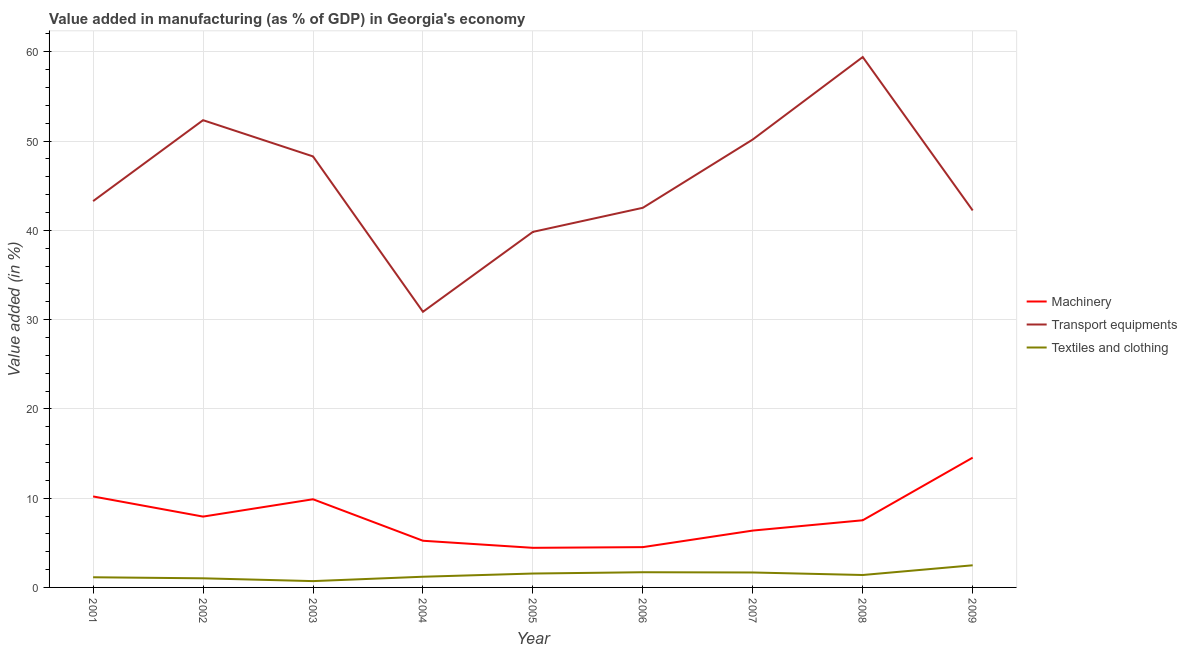Does the line corresponding to value added in manufacturing machinery intersect with the line corresponding to value added in manufacturing textile and clothing?
Keep it short and to the point. No. Is the number of lines equal to the number of legend labels?
Your answer should be very brief. Yes. What is the value added in manufacturing transport equipments in 2008?
Keep it short and to the point. 59.41. Across all years, what is the maximum value added in manufacturing machinery?
Provide a succinct answer. 14.54. Across all years, what is the minimum value added in manufacturing machinery?
Provide a short and direct response. 4.44. In which year was the value added in manufacturing transport equipments maximum?
Give a very brief answer. 2008. In which year was the value added in manufacturing transport equipments minimum?
Make the answer very short. 2004. What is the total value added in manufacturing transport equipments in the graph?
Offer a terse response. 408.9. What is the difference between the value added in manufacturing transport equipments in 2004 and that in 2009?
Your answer should be compact. -11.35. What is the difference between the value added in manufacturing machinery in 2008 and the value added in manufacturing transport equipments in 2005?
Your response must be concise. -32.3. What is the average value added in manufacturing textile and clothing per year?
Provide a short and direct response. 1.43. In the year 2005, what is the difference between the value added in manufacturing transport equipments and value added in manufacturing machinery?
Your response must be concise. 35.39. What is the ratio of the value added in manufacturing textile and clothing in 2004 to that in 2006?
Give a very brief answer. 0.7. Is the value added in manufacturing textile and clothing in 2003 less than that in 2004?
Your answer should be compact. Yes. Is the difference between the value added in manufacturing machinery in 2003 and 2007 greater than the difference between the value added in manufacturing transport equipments in 2003 and 2007?
Make the answer very short. Yes. What is the difference between the highest and the second highest value added in manufacturing machinery?
Your answer should be very brief. 4.35. What is the difference between the highest and the lowest value added in manufacturing machinery?
Ensure brevity in your answer.  10.1. In how many years, is the value added in manufacturing textile and clothing greater than the average value added in manufacturing textile and clothing taken over all years?
Make the answer very short. 4. Is the value added in manufacturing machinery strictly greater than the value added in manufacturing textile and clothing over the years?
Make the answer very short. Yes. How many lines are there?
Provide a short and direct response. 3. How many years are there in the graph?
Make the answer very short. 9. Are the values on the major ticks of Y-axis written in scientific E-notation?
Your answer should be very brief. No. Does the graph contain any zero values?
Provide a short and direct response. No. How many legend labels are there?
Keep it short and to the point. 3. What is the title of the graph?
Your answer should be compact. Value added in manufacturing (as % of GDP) in Georgia's economy. What is the label or title of the Y-axis?
Offer a very short reply. Value added (in %). What is the Value added (in %) in Machinery in 2001?
Offer a terse response. 10.19. What is the Value added (in %) of Transport equipments in 2001?
Keep it short and to the point. 43.27. What is the Value added (in %) of Textiles and clothing in 2001?
Your answer should be compact. 1.14. What is the Value added (in %) of Machinery in 2002?
Offer a very short reply. 7.93. What is the Value added (in %) in Transport equipments in 2002?
Provide a short and direct response. 52.33. What is the Value added (in %) in Textiles and clothing in 2002?
Your response must be concise. 1.02. What is the Value added (in %) of Machinery in 2003?
Make the answer very short. 9.88. What is the Value added (in %) of Transport equipments in 2003?
Ensure brevity in your answer.  48.28. What is the Value added (in %) of Textiles and clothing in 2003?
Your answer should be compact. 0.71. What is the Value added (in %) of Machinery in 2004?
Make the answer very short. 5.23. What is the Value added (in %) of Transport equipments in 2004?
Provide a short and direct response. 30.87. What is the Value added (in %) in Textiles and clothing in 2004?
Ensure brevity in your answer.  1.2. What is the Value added (in %) of Machinery in 2005?
Your answer should be very brief. 4.44. What is the Value added (in %) of Transport equipments in 2005?
Keep it short and to the point. 39.82. What is the Value added (in %) in Textiles and clothing in 2005?
Provide a short and direct response. 1.56. What is the Value added (in %) in Machinery in 2006?
Your answer should be very brief. 4.51. What is the Value added (in %) in Transport equipments in 2006?
Offer a terse response. 42.52. What is the Value added (in %) in Textiles and clothing in 2006?
Ensure brevity in your answer.  1.7. What is the Value added (in %) in Machinery in 2007?
Offer a terse response. 6.37. What is the Value added (in %) of Transport equipments in 2007?
Give a very brief answer. 50.17. What is the Value added (in %) in Textiles and clothing in 2007?
Make the answer very short. 1.67. What is the Value added (in %) of Machinery in 2008?
Offer a terse response. 7.52. What is the Value added (in %) of Transport equipments in 2008?
Provide a short and direct response. 59.41. What is the Value added (in %) in Textiles and clothing in 2008?
Your answer should be compact. 1.39. What is the Value added (in %) of Machinery in 2009?
Make the answer very short. 14.54. What is the Value added (in %) of Transport equipments in 2009?
Your answer should be very brief. 42.22. What is the Value added (in %) in Textiles and clothing in 2009?
Your answer should be compact. 2.48. Across all years, what is the maximum Value added (in %) in Machinery?
Keep it short and to the point. 14.54. Across all years, what is the maximum Value added (in %) in Transport equipments?
Provide a succinct answer. 59.41. Across all years, what is the maximum Value added (in %) in Textiles and clothing?
Give a very brief answer. 2.48. Across all years, what is the minimum Value added (in %) of Machinery?
Your response must be concise. 4.44. Across all years, what is the minimum Value added (in %) in Transport equipments?
Your answer should be very brief. 30.87. Across all years, what is the minimum Value added (in %) in Textiles and clothing?
Your answer should be very brief. 0.71. What is the total Value added (in %) of Machinery in the graph?
Your answer should be very brief. 70.61. What is the total Value added (in %) in Transport equipments in the graph?
Provide a short and direct response. 408.9. What is the total Value added (in %) in Textiles and clothing in the graph?
Your answer should be very brief. 12.87. What is the difference between the Value added (in %) of Machinery in 2001 and that in 2002?
Provide a short and direct response. 2.26. What is the difference between the Value added (in %) of Transport equipments in 2001 and that in 2002?
Your answer should be compact. -9.07. What is the difference between the Value added (in %) in Textiles and clothing in 2001 and that in 2002?
Offer a terse response. 0.12. What is the difference between the Value added (in %) of Machinery in 2001 and that in 2003?
Offer a very short reply. 0.31. What is the difference between the Value added (in %) in Transport equipments in 2001 and that in 2003?
Your answer should be very brief. -5.01. What is the difference between the Value added (in %) of Textiles and clothing in 2001 and that in 2003?
Give a very brief answer. 0.43. What is the difference between the Value added (in %) of Machinery in 2001 and that in 2004?
Offer a very short reply. 4.96. What is the difference between the Value added (in %) in Transport equipments in 2001 and that in 2004?
Keep it short and to the point. 12.4. What is the difference between the Value added (in %) in Textiles and clothing in 2001 and that in 2004?
Your answer should be compact. -0.06. What is the difference between the Value added (in %) in Machinery in 2001 and that in 2005?
Your response must be concise. 5.75. What is the difference between the Value added (in %) of Transport equipments in 2001 and that in 2005?
Offer a terse response. 3.44. What is the difference between the Value added (in %) of Textiles and clothing in 2001 and that in 2005?
Make the answer very short. -0.42. What is the difference between the Value added (in %) of Machinery in 2001 and that in 2006?
Make the answer very short. 5.68. What is the difference between the Value added (in %) of Transport equipments in 2001 and that in 2006?
Ensure brevity in your answer.  0.75. What is the difference between the Value added (in %) in Textiles and clothing in 2001 and that in 2006?
Make the answer very short. -0.56. What is the difference between the Value added (in %) of Machinery in 2001 and that in 2007?
Provide a succinct answer. 3.82. What is the difference between the Value added (in %) of Transport equipments in 2001 and that in 2007?
Provide a short and direct response. -6.9. What is the difference between the Value added (in %) in Textiles and clothing in 2001 and that in 2007?
Your answer should be compact. -0.54. What is the difference between the Value added (in %) of Machinery in 2001 and that in 2008?
Provide a succinct answer. 2.67. What is the difference between the Value added (in %) in Transport equipments in 2001 and that in 2008?
Offer a very short reply. -16.14. What is the difference between the Value added (in %) in Textiles and clothing in 2001 and that in 2008?
Keep it short and to the point. -0.25. What is the difference between the Value added (in %) of Machinery in 2001 and that in 2009?
Provide a short and direct response. -4.35. What is the difference between the Value added (in %) of Transport equipments in 2001 and that in 2009?
Provide a succinct answer. 1.04. What is the difference between the Value added (in %) of Textiles and clothing in 2001 and that in 2009?
Provide a short and direct response. -1.34. What is the difference between the Value added (in %) of Machinery in 2002 and that in 2003?
Ensure brevity in your answer.  -1.94. What is the difference between the Value added (in %) in Transport equipments in 2002 and that in 2003?
Your answer should be very brief. 4.06. What is the difference between the Value added (in %) in Textiles and clothing in 2002 and that in 2003?
Give a very brief answer. 0.31. What is the difference between the Value added (in %) in Machinery in 2002 and that in 2004?
Your response must be concise. 2.71. What is the difference between the Value added (in %) in Transport equipments in 2002 and that in 2004?
Your answer should be very brief. 21.46. What is the difference between the Value added (in %) of Textiles and clothing in 2002 and that in 2004?
Your answer should be compact. -0.18. What is the difference between the Value added (in %) in Machinery in 2002 and that in 2005?
Ensure brevity in your answer.  3.5. What is the difference between the Value added (in %) in Transport equipments in 2002 and that in 2005?
Your answer should be compact. 12.51. What is the difference between the Value added (in %) of Textiles and clothing in 2002 and that in 2005?
Give a very brief answer. -0.54. What is the difference between the Value added (in %) of Machinery in 2002 and that in 2006?
Offer a terse response. 3.42. What is the difference between the Value added (in %) of Transport equipments in 2002 and that in 2006?
Your response must be concise. 9.81. What is the difference between the Value added (in %) of Textiles and clothing in 2002 and that in 2006?
Your response must be concise. -0.68. What is the difference between the Value added (in %) of Machinery in 2002 and that in 2007?
Offer a very short reply. 1.57. What is the difference between the Value added (in %) in Transport equipments in 2002 and that in 2007?
Your answer should be compact. 2.16. What is the difference between the Value added (in %) in Textiles and clothing in 2002 and that in 2007?
Give a very brief answer. -0.65. What is the difference between the Value added (in %) of Machinery in 2002 and that in 2008?
Provide a succinct answer. 0.41. What is the difference between the Value added (in %) in Transport equipments in 2002 and that in 2008?
Give a very brief answer. -7.07. What is the difference between the Value added (in %) of Textiles and clothing in 2002 and that in 2008?
Your answer should be compact. -0.37. What is the difference between the Value added (in %) of Machinery in 2002 and that in 2009?
Your answer should be very brief. -6.6. What is the difference between the Value added (in %) in Transport equipments in 2002 and that in 2009?
Your response must be concise. 10.11. What is the difference between the Value added (in %) in Textiles and clothing in 2002 and that in 2009?
Your response must be concise. -1.46. What is the difference between the Value added (in %) in Machinery in 2003 and that in 2004?
Offer a terse response. 4.65. What is the difference between the Value added (in %) in Transport equipments in 2003 and that in 2004?
Make the answer very short. 17.4. What is the difference between the Value added (in %) in Textiles and clothing in 2003 and that in 2004?
Your answer should be very brief. -0.49. What is the difference between the Value added (in %) in Machinery in 2003 and that in 2005?
Ensure brevity in your answer.  5.44. What is the difference between the Value added (in %) of Transport equipments in 2003 and that in 2005?
Make the answer very short. 8.45. What is the difference between the Value added (in %) of Textiles and clothing in 2003 and that in 2005?
Make the answer very short. -0.85. What is the difference between the Value added (in %) in Machinery in 2003 and that in 2006?
Your response must be concise. 5.36. What is the difference between the Value added (in %) of Transport equipments in 2003 and that in 2006?
Your answer should be compact. 5.75. What is the difference between the Value added (in %) of Textiles and clothing in 2003 and that in 2006?
Keep it short and to the point. -0.99. What is the difference between the Value added (in %) of Machinery in 2003 and that in 2007?
Your answer should be compact. 3.51. What is the difference between the Value added (in %) of Transport equipments in 2003 and that in 2007?
Offer a very short reply. -1.9. What is the difference between the Value added (in %) of Textiles and clothing in 2003 and that in 2007?
Offer a very short reply. -0.96. What is the difference between the Value added (in %) in Machinery in 2003 and that in 2008?
Provide a short and direct response. 2.35. What is the difference between the Value added (in %) of Transport equipments in 2003 and that in 2008?
Your answer should be very brief. -11.13. What is the difference between the Value added (in %) in Textiles and clothing in 2003 and that in 2008?
Your answer should be compact. -0.68. What is the difference between the Value added (in %) of Machinery in 2003 and that in 2009?
Make the answer very short. -4.66. What is the difference between the Value added (in %) of Transport equipments in 2003 and that in 2009?
Your answer should be compact. 6.05. What is the difference between the Value added (in %) in Textiles and clothing in 2003 and that in 2009?
Your response must be concise. -1.77. What is the difference between the Value added (in %) of Machinery in 2004 and that in 2005?
Provide a succinct answer. 0.79. What is the difference between the Value added (in %) in Transport equipments in 2004 and that in 2005?
Offer a terse response. -8.95. What is the difference between the Value added (in %) in Textiles and clothing in 2004 and that in 2005?
Your answer should be very brief. -0.36. What is the difference between the Value added (in %) of Machinery in 2004 and that in 2006?
Your response must be concise. 0.71. What is the difference between the Value added (in %) in Transport equipments in 2004 and that in 2006?
Give a very brief answer. -11.65. What is the difference between the Value added (in %) in Textiles and clothing in 2004 and that in 2006?
Your answer should be very brief. -0.51. What is the difference between the Value added (in %) of Machinery in 2004 and that in 2007?
Give a very brief answer. -1.14. What is the difference between the Value added (in %) in Transport equipments in 2004 and that in 2007?
Your response must be concise. -19.3. What is the difference between the Value added (in %) in Textiles and clothing in 2004 and that in 2007?
Provide a short and direct response. -0.48. What is the difference between the Value added (in %) of Machinery in 2004 and that in 2008?
Provide a short and direct response. -2.29. What is the difference between the Value added (in %) in Transport equipments in 2004 and that in 2008?
Your response must be concise. -28.53. What is the difference between the Value added (in %) of Textiles and clothing in 2004 and that in 2008?
Give a very brief answer. -0.2. What is the difference between the Value added (in %) in Machinery in 2004 and that in 2009?
Keep it short and to the point. -9.31. What is the difference between the Value added (in %) in Transport equipments in 2004 and that in 2009?
Give a very brief answer. -11.35. What is the difference between the Value added (in %) of Textiles and clothing in 2004 and that in 2009?
Ensure brevity in your answer.  -1.28. What is the difference between the Value added (in %) in Machinery in 2005 and that in 2006?
Provide a short and direct response. -0.08. What is the difference between the Value added (in %) in Transport equipments in 2005 and that in 2006?
Your answer should be compact. -2.7. What is the difference between the Value added (in %) in Textiles and clothing in 2005 and that in 2006?
Make the answer very short. -0.15. What is the difference between the Value added (in %) in Machinery in 2005 and that in 2007?
Make the answer very short. -1.93. What is the difference between the Value added (in %) of Transport equipments in 2005 and that in 2007?
Your response must be concise. -10.35. What is the difference between the Value added (in %) in Textiles and clothing in 2005 and that in 2007?
Your response must be concise. -0.12. What is the difference between the Value added (in %) of Machinery in 2005 and that in 2008?
Ensure brevity in your answer.  -3.09. What is the difference between the Value added (in %) of Transport equipments in 2005 and that in 2008?
Offer a terse response. -19.58. What is the difference between the Value added (in %) of Textiles and clothing in 2005 and that in 2008?
Give a very brief answer. 0.16. What is the difference between the Value added (in %) in Machinery in 2005 and that in 2009?
Offer a very short reply. -10.1. What is the difference between the Value added (in %) of Textiles and clothing in 2005 and that in 2009?
Provide a succinct answer. -0.92. What is the difference between the Value added (in %) of Machinery in 2006 and that in 2007?
Your response must be concise. -1.86. What is the difference between the Value added (in %) in Transport equipments in 2006 and that in 2007?
Make the answer very short. -7.65. What is the difference between the Value added (in %) of Textiles and clothing in 2006 and that in 2007?
Your response must be concise. 0.03. What is the difference between the Value added (in %) in Machinery in 2006 and that in 2008?
Provide a short and direct response. -3.01. What is the difference between the Value added (in %) of Transport equipments in 2006 and that in 2008?
Give a very brief answer. -16.89. What is the difference between the Value added (in %) in Textiles and clothing in 2006 and that in 2008?
Your answer should be compact. 0.31. What is the difference between the Value added (in %) in Machinery in 2006 and that in 2009?
Your response must be concise. -10.02. What is the difference between the Value added (in %) in Transport equipments in 2006 and that in 2009?
Your answer should be compact. 0.3. What is the difference between the Value added (in %) of Textiles and clothing in 2006 and that in 2009?
Provide a succinct answer. -0.78. What is the difference between the Value added (in %) in Machinery in 2007 and that in 2008?
Give a very brief answer. -1.15. What is the difference between the Value added (in %) of Transport equipments in 2007 and that in 2008?
Your answer should be compact. -9.23. What is the difference between the Value added (in %) of Textiles and clothing in 2007 and that in 2008?
Give a very brief answer. 0.28. What is the difference between the Value added (in %) in Machinery in 2007 and that in 2009?
Your response must be concise. -8.17. What is the difference between the Value added (in %) of Transport equipments in 2007 and that in 2009?
Offer a terse response. 7.95. What is the difference between the Value added (in %) in Textiles and clothing in 2007 and that in 2009?
Your answer should be very brief. -0.81. What is the difference between the Value added (in %) in Machinery in 2008 and that in 2009?
Keep it short and to the point. -7.02. What is the difference between the Value added (in %) of Transport equipments in 2008 and that in 2009?
Offer a terse response. 17.18. What is the difference between the Value added (in %) in Textiles and clothing in 2008 and that in 2009?
Provide a succinct answer. -1.09. What is the difference between the Value added (in %) of Machinery in 2001 and the Value added (in %) of Transport equipments in 2002?
Offer a terse response. -42.14. What is the difference between the Value added (in %) in Machinery in 2001 and the Value added (in %) in Textiles and clothing in 2002?
Provide a short and direct response. 9.17. What is the difference between the Value added (in %) of Transport equipments in 2001 and the Value added (in %) of Textiles and clothing in 2002?
Your answer should be compact. 42.25. What is the difference between the Value added (in %) in Machinery in 2001 and the Value added (in %) in Transport equipments in 2003?
Keep it short and to the point. -38.09. What is the difference between the Value added (in %) in Machinery in 2001 and the Value added (in %) in Textiles and clothing in 2003?
Your answer should be very brief. 9.48. What is the difference between the Value added (in %) in Transport equipments in 2001 and the Value added (in %) in Textiles and clothing in 2003?
Provide a succinct answer. 42.56. What is the difference between the Value added (in %) of Machinery in 2001 and the Value added (in %) of Transport equipments in 2004?
Provide a succinct answer. -20.68. What is the difference between the Value added (in %) in Machinery in 2001 and the Value added (in %) in Textiles and clothing in 2004?
Give a very brief answer. 8.99. What is the difference between the Value added (in %) of Transport equipments in 2001 and the Value added (in %) of Textiles and clothing in 2004?
Keep it short and to the point. 42.07. What is the difference between the Value added (in %) in Machinery in 2001 and the Value added (in %) in Transport equipments in 2005?
Your response must be concise. -29.63. What is the difference between the Value added (in %) of Machinery in 2001 and the Value added (in %) of Textiles and clothing in 2005?
Your answer should be compact. 8.63. What is the difference between the Value added (in %) of Transport equipments in 2001 and the Value added (in %) of Textiles and clothing in 2005?
Ensure brevity in your answer.  41.71. What is the difference between the Value added (in %) in Machinery in 2001 and the Value added (in %) in Transport equipments in 2006?
Give a very brief answer. -32.33. What is the difference between the Value added (in %) of Machinery in 2001 and the Value added (in %) of Textiles and clothing in 2006?
Offer a very short reply. 8.49. What is the difference between the Value added (in %) of Transport equipments in 2001 and the Value added (in %) of Textiles and clothing in 2006?
Provide a short and direct response. 41.57. What is the difference between the Value added (in %) in Machinery in 2001 and the Value added (in %) in Transport equipments in 2007?
Ensure brevity in your answer.  -39.98. What is the difference between the Value added (in %) in Machinery in 2001 and the Value added (in %) in Textiles and clothing in 2007?
Offer a terse response. 8.52. What is the difference between the Value added (in %) in Transport equipments in 2001 and the Value added (in %) in Textiles and clothing in 2007?
Provide a succinct answer. 41.6. What is the difference between the Value added (in %) of Machinery in 2001 and the Value added (in %) of Transport equipments in 2008?
Keep it short and to the point. -49.22. What is the difference between the Value added (in %) in Machinery in 2001 and the Value added (in %) in Textiles and clothing in 2008?
Ensure brevity in your answer.  8.8. What is the difference between the Value added (in %) in Transport equipments in 2001 and the Value added (in %) in Textiles and clothing in 2008?
Your answer should be very brief. 41.88. What is the difference between the Value added (in %) in Machinery in 2001 and the Value added (in %) in Transport equipments in 2009?
Offer a terse response. -32.03. What is the difference between the Value added (in %) in Machinery in 2001 and the Value added (in %) in Textiles and clothing in 2009?
Offer a terse response. 7.71. What is the difference between the Value added (in %) in Transport equipments in 2001 and the Value added (in %) in Textiles and clothing in 2009?
Your answer should be compact. 40.79. What is the difference between the Value added (in %) of Machinery in 2002 and the Value added (in %) of Transport equipments in 2003?
Your response must be concise. -40.34. What is the difference between the Value added (in %) in Machinery in 2002 and the Value added (in %) in Textiles and clothing in 2003?
Ensure brevity in your answer.  7.23. What is the difference between the Value added (in %) of Transport equipments in 2002 and the Value added (in %) of Textiles and clothing in 2003?
Your answer should be compact. 51.63. What is the difference between the Value added (in %) of Machinery in 2002 and the Value added (in %) of Transport equipments in 2004?
Your answer should be very brief. -22.94. What is the difference between the Value added (in %) in Machinery in 2002 and the Value added (in %) in Textiles and clothing in 2004?
Your response must be concise. 6.74. What is the difference between the Value added (in %) in Transport equipments in 2002 and the Value added (in %) in Textiles and clothing in 2004?
Provide a short and direct response. 51.14. What is the difference between the Value added (in %) of Machinery in 2002 and the Value added (in %) of Transport equipments in 2005?
Offer a very short reply. -31.89. What is the difference between the Value added (in %) of Machinery in 2002 and the Value added (in %) of Textiles and clothing in 2005?
Offer a terse response. 6.38. What is the difference between the Value added (in %) in Transport equipments in 2002 and the Value added (in %) in Textiles and clothing in 2005?
Your response must be concise. 50.78. What is the difference between the Value added (in %) of Machinery in 2002 and the Value added (in %) of Transport equipments in 2006?
Offer a terse response. -34.59. What is the difference between the Value added (in %) of Machinery in 2002 and the Value added (in %) of Textiles and clothing in 2006?
Provide a succinct answer. 6.23. What is the difference between the Value added (in %) of Transport equipments in 2002 and the Value added (in %) of Textiles and clothing in 2006?
Give a very brief answer. 50.63. What is the difference between the Value added (in %) of Machinery in 2002 and the Value added (in %) of Transport equipments in 2007?
Your response must be concise. -42.24. What is the difference between the Value added (in %) of Machinery in 2002 and the Value added (in %) of Textiles and clothing in 2007?
Ensure brevity in your answer.  6.26. What is the difference between the Value added (in %) of Transport equipments in 2002 and the Value added (in %) of Textiles and clothing in 2007?
Provide a short and direct response. 50.66. What is the difference between the Value added (in %) of Machinery in 2002 and the Value added (in %) of Transport equipments in 2008?
Give a very brief answer. -51.47. What is the difference between the Value added (in %) of Machinery in 2002 and the Value added (in %) of Textiles and clothing in 2008?
Your response must be concise. 6.54. What is the difference between the Value added (in %) of Transport equipments in 2002 and the Value added (in %) of Textiles and clothing in 2008?
Provide a succinct answer. 50.94. What is the difference between the Value added (in %) in Machinery in 2002 and the Value added (in %) in Transport equipments in 2009?
Provide a short and direct response. -34.29. What is the difference between the Value added (in %) of Machinery in 2002 and the Value added (in %) of Textiles and clothing in 2009?
Your answer should be compact. 5.45. What is the difference between the Value added (in %) of Transport equipments in 2002 and the Value added (in %) of Textiles and clothing in 2009?
Provide a short and direct response. 49.85. What is the difference between the Value added (in %) of Machinery in 2003 and the Value added (in %) of Transport equipments in 2004?
Offer a terse response. -21. What is the difference between the Value added (in %) of Machinery in 2003 and the Value added (in %) of Textiles and clothing in 2004?
Make the answer very short. 8.68. What is the difference between the Value added (in %) in Transport equipments in 2003 and the Value added (in %) in Textiles and clothing in 2004?
Your answer should be compact. 47.08. What is the difference between the Value added (in %) in Machinery in 2003 and the Value added (in %) in Transport equipments in 2005?
Provide a succinct answer. -29.95. What is the difference between the Value added (in %) in Machinery in 2003 and the Value added (in %) in Textiles and clothing in 2005?
Offer a terse response. 8.32. What is the difference between the Value added (in %) of Transport equipments in 2003 and the Value added (in %) of Textiles and clothing in 2005?
Keep it short and to the point. 46.72. What is the difference between the Value added (in %) in Machinery in 2003 and the Value added (in %) in Transport equipments in 2006?
Give a very brief answer. -32.65. What is the difference between the Value added (in %) of Machinery in 2003 and the Value added (in %) of Textiles and clothing in 2006?
Your response must be concise. 8.17. What is the difference between the Value added (in %) in Transport equipments in 2003 and the Value added (in %) in Textiles and clothing in 2006?
Provide a succinct answer. 46.57. What is the difference between the Value added (in %) in Machinery in 2003 and the Value added (in %) in Transport equipments in 2007?
Offer a terse response. -40.3. What is the difference between the Value added (in %) of Machinery in 2003 and the Value added (in %) of Textiles and clothing in 2007?
Provide a succinct answer. 8.2. What is the difference between the Value added (in %) in Transport equipments in 2003 and the Value added (in %) in Textiles and clothing in 2007?
Offer a terse response. 46.6. What is the difference between the Value added (in %) of Machinery in 2003 and the Value added (in %) of Transport equipments in 2008?
Provide a succinct answer. -49.53. What is the difference between the Value added (in %) of Machinery in 2003 and the Value added (in %) of Textiles and clothing in 2008?
Your answer should be compact. 8.48. What is the difference between the Value added (in %) in Transport equipments in 2003 and the Value added (in %) in Textiles and clothing in 2008?
Keep it short and to the point. 46.88. What is the difference between the Value added (in %) of Machinery in 2003 and the Value added (in %) of Transport equipments in 2009?
Provide a succinct answer. -32.35. What is the difference between the Value added (in %) in Machinery in 2003 and the Value added (in %) in Textiles and clothing in 2009?
Offer a terse response. 7.4. What is the difference between the Value added (in %) of Transport equipments in 2003 and the Value added (in %) of Textiles and clothing in 2009?
Your answer should be very brief. 45.8. What is the difference between the Value added (in %) in Machinery in 2004 and the Value added (in %) in Transport equipments in 2005?
Keep it short and to the point. -34.6. What is the difference between the Value added (in %) of Machinery in 2004 and the Value added (in %) of Textiles and clothing in 2005?
Ensure brevity in your answer.  3.67. What is the difference between the Value added (in %) in Transport equipments in 2004 and the Value added (in %) in Textiles and clothing in 2005?
Provide a succinct answer. 29.32. What is the difference between the Value added (in %) in Machinery in 2004 and the Value added (in %) in Transport equipments in 2006?
Keep it short and to the point. -37.29. What is the difference between the Value added (in %) in Machinery in 2004 and the Value added (in %) in Textiles and clothing in 2006?
Offer a very short reply. 3.53. What is the difference between the Value added (in %) of Transport equipments in 2004 and the Value added (in %) of Textiles and clothing in 2006?
Your answer should be very brief. 29.17. What is the difference between the Value added (in %) of Machinery in 2004 and the Value added (in %) of Transport equipments in 2007?
Offer a very short reply. -44.95. What is the difference between the Value added (in %) in Machinery in 2004 and the Value added (in %) in Textiles and clothing in 2007?
Your answer should be very brief. 3.55. What is the difference between the Value added (in %) in Transport equipments in 2004 and the Value added (in %) in Textiles and clothing in 2007?
Make the answer very short. 29.2. What is the difference between the Value added (in %) of Machinery in 2004 and the Value added (in %) of Transport equipments in 2008?
Your answer should be compact. -54.18. What is the difference between the Value added (in %) in Machinery in 2004 and the Value added (in %) in Textiles and clothing in 2008?
Provide a succinct answer. 3.84. What is the difference between the Value added (in %) of Transport equipments in 2004 and the Value added (in %) of Textiles and clothing in 2008?
Give a very brief answer. 29.48. What is the difference between the Value added (in %) in Machinery in 2004 and the Value added (in %) in Transport equipments in 2009?
Your answer should be very brief. -37. What is the difference between the Value added (in %) in Machinery in 2004 and the Value added (in %) in Textiles and clothing in 2009?
Offer a very short reply. 2.75. What is the difference between the Value added (in %) in Transport equipments in 2004 and the Value added (in %) in Textiles and clothing in 2009?
Offer a terse response. 28.39. What is the difference between the Value added (in %) in Machinery in 2005 and the Value added (in %) in Transport equipments in 2006?
Keep it short and to the point. -38.09. What is the difference between the Value added (in %) in Machinery in 2005 and the Value added (in %) in Textiles and clothing in 2006?
Keep it short and to the point. 2.73. What is the difference between the Value added (in %) of Transport equipments in 2005 and the Value added (in %) of Textiles and clothing in 2006?
Provide a succinct answer. 38.12. What is the difference between the Value added (in %) of Machinery in 2005 and the Value added (in %) of Transport equipments in 2007?
Provide a short and direct response. -45.74. What is the difference between the Value added (in %) in Machinery in 2005 and the Value added (in %) in Textiles and clothing in 2007?
Offer a very short reply. 2.76. What is the difference between the Value added (in %) in Transport equipments in 2005 and the Value added (in %) in Textiles and clothing in 2007?
Offer a very short reply. 38.15. What is the difference between the Value added (in %) in Machinery in 2005 and the Value added (in %) in Transport equipments in 2008?
Make the answer very short. -54.97. What is the difference between the Value added (in %) of Machinery in 2005 and the Value added (in %) of Textiles and clothing in 2008?
Offer a very short reply. 3.04. What is the difference between the Value added (in %) of Transport equipments in 2005 and the Value added (in %) of Textiles and clothing in 2008?
Your response must be concise. 38.43. What is the difference between the Value added (in %) in Machinery in 2005 and the Value added (in %) in Transport equipments in 2009?
Make the answer very short. -37.79. What is the difference between the Value added (in %) in Machinery in 2005 and the Value added (in %) in Textiles and clothing in 2009?
Make the answer very short. 1.96. What is the difference between the Value added (in %) in Transport equipments in 2005 and the Value added (in %) in Textiles and clothing in 2009?
Provide a succinct answer. 37.34. What is the difference between the Value added (in %) of Machinery in 2006 and the Value added (in %) of Transport equipments in 2007?
Offer a very short reply. -45.66. What is the difference between the Value added (in %) of Machinery in 2006 and the Value added (in %) of Textiles and clothing in 2007?
Your response must be concise. 2.84. What is the difference between the Value added (in %) in Transport equipments in 2006 and the Value added (in %) in Textiles and clothing in 2007?
Your answer should be compact. 40.85. What is the difference between the Value added (in %) in Machinery in 2006 and the Value added (in %) in Transport equipments in 2008?
Keep it short and to the point. -54.89. What is the difference between the Value added (in %) in Machinery in 2006 and the Value added (in %) in Textiles and clothing in 2008?
Your answer should be compact. 3.12. What is the difference between the Value added (in %) in Transport equipments in 2006 and the Value added (in %) in Textiles and clothing in 2008?
Keep it short and to the point. 41.13. What is the difference between the Value added (in %) in Machinery in 2006 and the Value added (in %) in Transport equipments in 2009?
Your response must be concise. -37.71. What is the difference between the Value added (in %) of Machinery in 2006 and the Value added (in %) of Textiles and clothing in 2009?
Provide a succinct answer. 2.03. What is the difference between the Value added (in %) of Transport equipments in 2006 and the Value added (in %) of Textiles and clothing in 2009?
Ensure brevity in your answer.  40.04. What is the difference between the Value added (in %) in Machinery in 2007 and the Value added (in %) in Transport equipments in 2008?
Your answer should be very brief. -53.04. What is the difference between the Value added (in %) of Machinery in 2007 and the Value added (in %) of Textiles and clothing in 2008?
Keep it short and to the point. 4.98. What is the difference between the Value added (in %) in Transport equipments in 2007 and the Value added (in %) in Textiles and clothing in 2008?
Give a very brief answer. 48.78. What is the difference between the Value added (in %) in Machinery in 2007 and the Value added (in %) in Transport equipments in 2009?
Ensure brevity in your answer.  -35.86. What is the difference between the Value added (in %) in Machinery in 2007 and the Value added (in %) in Textiles and clothing in 2009?
Provide a succinct answer. 3.89. What is the difference between the Value added (in %) in Transport equipments in 2007 and the Value added (in %) in Textiles and clothing in 2009?
Ensure brevity in your answer.  47.69. What is the difference between the Value added (in %) in Machinery in 2008 and the Value added (in %) in Transport equipments in 2009?
Ensure brevity in your answer.  -34.7. What is the difference between the Value added (in %) of Machinery in 2008 and the Value added (in %) of Textiles and clothing in 2009?
Keep it short and to the point. 5.04. What is the difference between the Value added (in %) in Transport equipments in 2008 and the Value added (in %) in Textiles and clothing in 2009?
Offer a very short reply. 56.93. What is the average Value added (in %) of Machinery per year?
Your answer should be compact. 7.85. What is the average Value added (in %) in Transport equipments per year?
Offer a very short reply. 45.43. What is the average Value added (in %) in Textiles and clothing per year?
Provide a succinct answer. 1.43. In the year 2001, what is the difference between the Value added (in %) in Machinery and Value added (in %) in Transport equipments?
Give a very brief answer. -33.08. In the year 2001, what is the difference between the Value added (in %) in Machinery and Value added (in %) in Textiles and clothing?
Provide a succinct answer. 9.05. In the year 2001, what is the difference between the Value added (in %) of Transport equipments and Value added (in %) of Textiles and clothing?
Give a very brief answer. 42.13. In the year 2002, what is the difference between the Value added (in %) of Machinery and Value added (in %) of Transport equipments?
Your response must be concise. -44.4. In the year 2002, what is the difference between the Value added (in %) of Machinery and Value added (in %) of Textiles and clothing?
Offer a terse response. 6.91. In the year 2002, what is the difference between the Value added (in %) in Transport equipments and Value added (in %) in Textiles and clothing?
Offer a very short reply. 51.31. In the year 2003, what is the difference between the Value added (in %) of Machinery and Value added (in %) of Transport equipments?
Your answer should be very brief. -38.4. In the year 2003, what is the difference between the Value added (in %) in Machinery and Value added (in %) in Textiles and clothing?
Offer a very short reply. 9.17. In the year 2003, what is the difference between the Value added (in %) in Transport equipments and Value added (in %) in Textiles and clothing?
Provide a succinct answer. 47.57. In the year 2004, what is the difference between the Value added (in %) of Machinery and Value added (in %) of Transport equipments?
Give a very brief answer. -25.65. In the year 2004, what is the difference between the Value added (in %) in Machinery and Value added (in %) in Textiles and clothing?
Give a very brief answer. 4.03. In the year 2004, what is the difference between the Value added (in %) in Transport equipments and Value added (in %) in Textiles and clothing?
Your response must be concise. 29.68. In the year 2005, what is the difference between the Value added (in %) of Machinery and Value added (in %) of Transport equipments?
Offer a terse response. -35.39. In the year 2005, what is the difference between the Value added (in %) of Machinery and Value added (in %) of Textiles and clothing?
Ensure brevity in your answer.  2.88. In the year 2005, what is the difference between the Value added (in %) of Transport equipments and Value added (in %) of Textiles and clothing?
Keep it short and to the point. 38.27. In the year 2006, what is the difference between the Value added (in %) in Machinery and Value added (in %) in Transport equipments?
Make the answer very short. -38.01. In the year 2006, what is the difference between the Value added (in %) in Machinery and Value added (in %) in Textiles and clothing?
Offer a terse response. 2.81. In the year 2006, what is the difference between the Value added (in %) in Transport equipments and Value added (in %) in Textiles and clothing?
Make the answer very short. 40.82. In the year 2007, what is the difference between the Value added (in %) of Machinery and Value added (in %) of Transport equipments?
Provide a succinct answer. -43.81. In the year 2007, what is the difference between the Value added (in %) in Machinery and Value added (in %) in Textiles and clothing?
Your answer should be compact. 4.7. In the year 2007, what is the difference between the Value added (in %) of Transport equipments and Value added (in %) of Textiles and clothing?
Your answer should be compact. 48.5. In the year 2008, what is the difference between the Value added (in %) in Machinery and Value added (in %) in Transport equipments?
Provide a succinct answer. -51.89. In the year 2008, what is the difference between the Value added (in %) in Machinery and Value added (in %) in Textiles and clothing?
Provide a short and direct response. 6.13. In the year 2008, what is the difference between the Value added (in %) in Transport equipments and Value added (in %) in Textiles and clothing?
Keep it short and to the point. 58.02. In the year 2009, what is the difference between the Value added (in %) in Machinery and Value added (in %) in Transport equipments?
Provide a succinct answer. -27.69. In the year 2009, what is the difference between the Value added (in %) in Machinery and Value added (in %) in Textiles and clothing?
Offer a terse response. 12.06. In the year 2009, what is the difference between the Value added (in %) in Transport equipments and Value added (in %) in Textiles and clothing?
Give a very brief answer. 39.74. What is the ratio of the Value added (in %) of Machinery in 2001 to that in 2002?
Offer a very short reply. 1.28. What is the ratio of the Value added (in %) in Transport equipments in 2001 to that in 2002?
Provide a short and direct response. 0.83. What is the ratio of the Value added (in %) in Textiles and clothing in 2001 to that in 2002?
Provide a succinct answer. 1.11. What is the ratio of the Value added (in %) of Machinery in 2001 to that in 2003?
Make the answer very short. 1.03. What is the ratio of the Value added (in %) of Transport equipments in 2001 to that in 2003?
Your response must be concise. 0.9. What is the ratio of the Value added (in %) of Textiles and clothing in 2001 to that in 2003?
Your answer should be compact. 1.61. What is the ratio of the Value added (in %) in Machinery in 2001 to that in 2004?
Your answer should be compact. 1.95. What is the ratio of the Value added (in %) in Transport equipments in 2001 to that in 2004?
Make the answer very short. 1.4. What is the ratio of the Value added (in %) in Textiles and clothing in 2001 to that in 2004?
Ensure brevity in your answer.  0.95. What is the ratio of the Value added (in %) of Machinery in 2001 to that in 2005?
Give a very brief answer. 2.3. What is the ratio of the Value added (in %) in Transport equipments in 2001 to that in 2005?
Provide a short and direct response. 1.09. What is the ratio of the Value added (in %) of Textiles and clothing in 2001 to that in 2005?
Keep it short and to the point. 0.73. What is the ratio of the Value added (in %) in Machinery in 2001 to that in 2006?
Ensure brevity in your answer.  2.26. What is the ratio of the Value added (in %) of Transport equipments in 2001 to that in 2006?
Provide a short and direct response. 1.02. What is the ratio of the Value added (in %) in Textiles and clothing in 2001 to that in 2006?
Your answer should be very brief. 0.67. What is the ratio of the Value added (in %) in Machinery in 2001 to that in 2007?
Provide a succinct answer. 1.6. What is the ratio of the Value added (in %) in Transport equipments in 2001 to that in 2007?
Provide a short and direct response. 0.86. What is the ratio of the Value added (in %) of Textiles and clothing in 2001 to that in 2007?
Your response must be concise. 0.68. What is the ratio of the Value added (in %) in Machinery in 2001 to that in 2008?
Your response must be concise. 1.35. What is the ratio of the Value added (in %) of Transport equipments in 2001 to that in 2008?
Provide a succinct answer. 0.73. What is the ratio of the Value added (in %) in Textiles and clothing in 2001 to that in 2008?
Offer a very short reply. 0.82. What is the ratio of the Value added (in %) of Machinery in 2001 to that in 2009?
Make the answer very short. 0.7. What is the ratio of the Value added (in %) of Transport equipments in 2001 to that in 2009?
Give a very brief answer. 1.02. What is the ratio of the Value added (in %) of Textiles and clothing in 2001 to that in 2009?
Ensure brevity in your answer.  0.46. What is the ratio of the Value added (in %) in Machinery in 2002 to that in 2003?
Give a very brief answer. 0.8. What is the ratio of the Value added (in %) of Transport equipments in 2002 to that in 2003?
Provide a short and direct response. 1.08. What is the ratio of the Value added (in %) of Textiles and clothing in 2002 to that in 2003?
Your response must be concise. 1.44. What is the ratio of the Value added (in %) in Machinery in 2002 to that in 2004?
Keep it short and to the point. 1.52. What is the ratio of the Value added (in %) in Transport equipments in 2002 to that in 2004?
Make the answer very short. 1.7. What is the ratio of the Value added (in %) in Textiles and clothing in 2002 to that in 2004?
Your response must be concise. 0.85. What is the ratio of the Value added (in %) in Machinery in 2002 to that in 2005?
Give a very brief answer. 1.79. What is the ratio of the Value added (in %) in Transport equipments in 2002 to that in 2005?
Offer a very short reply. 1.31. What is the ratio of the Value added (in %) of Textiles and clothing in 2002 to that in 2005?
Make the answer very short. 0.66. What is the ratio of the Value added (in %) in Machinery in 2002 to that in 2006?
Your answer should be compact. 1.76. What is the ratio of the Value added (in %) of Transport equipments in 2002 to that in 2006?
Make the answer very short. 1.23. What is the ratio of the Value added (in %) in Machinery in 2002 to that in 2007?
Your answer should be compact. 1.25. What is the ratio of the Value added (in %) of Transport equipments in 2002 to that in 2007?
Make the answer very short. 1.04. What is the ratio of the Value added (in %) of Textiles and clothing in 2002 to that in 2007?
Give a very brief answer. 0.61. What is the ratio of the Value added (in %) in Machinery in 2002 to that in 2008?
Provide a succinct answer. 1.05. What is the ratio of the Value added (in %) of Transport equipments in 2002 to that in 2008?
Give a very brief answer. 0.88. What is the ratio of the Value added (in %) of Textiles and clothing in 2002 to that in 2008?
Offer a terse response. 0.73. What is the ratio of the Value added (in %) in Machinery in 2002 to that in 2009?
Your answer should be very brief. 0.55. What is the ratio of the Value added (in %) in Transport equipments in 2002 to that in 2009?
Provide a succinct answer. 1.24. What is the ratio of the Value added (in %) of Textiles and clothing in 2002 to that in 2009?
Ensure brevity in your answer.  0.41. What is the ratio of the Value added (in %) in Machinery in 2003 to that in 2004?
Provide a short and direct response. 1.89. What is the ratio of the Value added (in %) in Transport equipments in 2003 to that in 2004?
Keep it short and to the point. 1.56. What is the ratio of the Value added (in %) of Textiles and clothing in 2003 to that in 2004?
Give a very brief answer. 0.59. What is the ratio of the Value added (in %) of Machinery in 2003 to that in 2005?
Provide a succinct answer. 2.23. What is the ratio of the Value added (in %) in Transport equipments in 2003 to that in 2005?
Your answer should be very brief. 1.21. What is the ratio of the Value added (in %) in Textiles and clothing in 2003 to that in 2005?
Ensure brevity in your answer.  0.45. What is the ratio of the Value added (in %) of Machinery in 2003 to that in 2006?
Your answer should be very brief. 2.19. What is the ratio of the Value added (in %) in Transport equipments in 2003 to that in 2006?
Give a very brief answer. 1.14. What is the ratio of the Value added (in %) in Textiles and clothing in 2003 to that in 2006?
Keep it short and to the point. 0.42. What is the ratio of the Value added (in %) in Machinery in 2003 to that in 2007?
Your answer should be very brief. 1.55. What is the ratio of the Value added (in %) of Transport equipments in 2003 to that in 2007?
Make the answer very short. 0.96. What is the ratio of the Value added (in %) in Textiles and clothing in 2003 to that in 2007?
Provide a short and direct response. 0.42. What is the ratio of the Value added (in %) of Machinery in 2003 to that in 2008?
Your answer should be compact. 1.31. What is the ratio of the Value added (in %) in Transport equipments in 2003 to that in 2008?
Offer a terse response. 0.81. What is the ratio of the Value added (in %) of Textiles and clothing in 2003 to that in 2008?
Provide a succinct answer. 0.51. What is the ratio of the Value added (in %) of Machinery in 2003 to that in 2009?
Offer a very short reply. 0.68. What is the ratio of the Value added (in %) in Transport equipments in 2003 to that in 2009?
Offer a very short reply. 1.14. What is the ratio of the Value added (in %) in Textiles and clothing in 2003 to that in 2009?
Ensure brevity in your answer.  0.29. What is the ratio of the Value added (in %) of Machinery in 2004 to that in 2005?
Ensure brevity in your answer.  1.18. What is the ratio of the Value added (in %) of Transport equipments in 2004 to that in 2005?
Make the answer very short. 0.78. What is the ratio of the Value added (in %) in Textiles and clothing in 2004 to that in 2005?
Offer a very short reply. 0.77. What is the ratio of the Value added (in %) of Machinery in 2004 to that in 2006?
Offer a very short reply. 1.16. What is the ratio of the Value added (in %) of Transport equipments in 2004 to that in 2006?
Your answer should be very brief. 0.73. What is the ratio of the Value added (in %) of Textiles and clothing in 2004 to that in 2006?
Offer a very short reply. 0.7. What is the ratio of the Value added (in %) of Machinery in 2004 to that in 2007?
Your answer should be compact. 0.82. What is the ratio of the Value added (in %) of Transport equipments in 2004 to that in 2007?
Your response must be concise. 0.62. What is the ratio of the Value added (in %) of Textiles and clothing in 2004 to that in 2007?
Provide a short and direct response. 0.72. What is the ratio of the Value added (in %) in Machinery in 2004 to that in 2008?
Your response must be concise. 0.69. What is the ratio of the Value added (in %) of Transport equipments in 2004 to that in 2008?
Make the answer very short. 0.52. What is the ratio of the Value added (in %) in Textiles and clothing in 2004 to that in 2008?
Provide a succinct answer. 0.86. What is the ratio of the Value added (in %) of Machinery in 2004 to that in 2009?
Ensure brevity in your answer.  0.36. What is the ratio of the Value added (in %) in Transport equipments in 2004 to that in 2009?
Offer a very short reply. 0.73. What is the ratio of the Value added (in %) in Textiles and clothing in 2004 to that in 2009?
Make the answer very short. 0.48. What is the ratio of the Value added (in %) in Machinery in 2005 to that in 2006?
Make the answer very short. 0.98. What is the ratio of the Value added (in %) in Transport equipments in 2005 to that in 2006?
Offer a terse response. 0.94. What is the ratio of the Value added (in %) of Textiles and clothing in 2005 to that in 2006?
Provide a short and direct response. 0.91. What is the ratio of the Value added (in %) in Machinery in 2005 to that in 2007?
Your answer should be very brief. 0.7. What is the ratio of the Value added (in %) in Transport equipments in 2005 to that in 2007?
Your answer should be compact. 0.79. What is the ratio of the Value added (in %) in Textiles and clothing in 2005 to that in 2007?
Provide a short and direct response. 0.93. What is the ratio of the Value added (in %) in Machinery in 2005 to that in 2008?
Your answer should be very brief. 0.59. What is the ratio of the Value added (in %) of Transport equipments in 2005 to that in 2008?
Make the answer very short. 0.67. What is the ratio of the Value added (in %) in Textiles and clothing in 2005 to that in 2008?
Your answer should be compact. 1.12. What is the ratio of the Value added (in %) of Machinery in 2005 to that in 2009?
Offer a very short reply. 0.31. What is the ratio of the Value added (in %) of Transport equipments in 2005 to that in 2009?
Provide a short and direct response. 0.94. What is the ratio of the Value added (in %) in Textiles and clothing in 2005 to that in 2009?
Give a very brief answer. 0.63. What is the ratio of the Value added (in %) of Machinery in 2006 to that in 2007?
Keep it short and to the point. 0.71. What is the ratio of the Value added (in %) of Transport equipments in 2006 to that in 2007?
Your answer should be compact. 0.85. What is the ratio of the Value added (in %) in Textiles and clothing in 2006 to that in 2007?
Your answer should be compact. 1.02. What is the ratio of the Value added (in %) of Machinery in 2006 to that in 2008?
Your answer should be compact. 0.6. What is the ratio of the Value added (in %) in Transport equipments in 2006 to that in 2008?
Give a very brief answer. 0.72. What is the ratio of the Value added (in %) in Textiles and clothing in 2006 to that in 2008?
Offer a terse response. 1.22. What is the ratio of the Value added (in %) in Machinery in 2006 to that in 2009?
Your answer should be very brief. 0.31. What is the ratio of the Value added (in %) of Transport equipments in 2006 to that in 2009?
Your answer should be very brief. 1.01. What is the ratio of the Value added (in %) in Textiles and clothing in 2006 to that in 2009?
Your response must be concise. 0.69. What is the ratio of the Value added (in %) of Machinery in 2007 to that in 2008?
Ensure brevity in your answer.  0.85. What is the ratio of the Value added (in %) in Transport equipments in 2007 to that in 2008?
Make the answer very short. 0.84. What is the ratio of the Value added (in %) in Textiles and clothing in 2007 to that in 2008?
Ensure brevity in your answer.  1.2. What is the ratio of the Value added (in %) of Machinery in 2007 to that in 2009?
Your response must be concise. 0.44. What is the ratio of the Value added (in %) in Transport equipments in 2007 to that in 2009?
Your answer should be very brief. 1.19. What is the ratio of the Value added (in %) in Textiles and clothing in 2007 to that in 2009?
Give a very brief answer. 0.67. What is the ratio of the Value added (in %) of Machinery in 2008 to that in 2009?
Your response must be concise. 0.52. What is the ratio of the Value added (in %) in Transport equipments in 2008 to that in 2009?
Provide a short and direct response. 1.41. What is the ratio of the Value added (in %) of Textiles and clothing in 2008 to that in 2009?
Your answer should be compact. 0.56. What is the difference between the highest and the second highest Value added (in %) in Machinery?
Ensure brevity in your answer.  4.35. What is the difference between the highest and the second highest Value added (in %) of Transport equipments?
Your response must be concise. 7.07. What is the difference between the highest and the second highest Value added (in %) of Textiles and clothing?
Your answer should be compact. 0.78. What is the difference between the highest and the lowest Value added (in %) of Machinery?
Your answer should be compact. 10.1. What is the difference between the highest and the lowest Value added (in %) in Transport equipments?
Provide a succinct answer. 28.53. What is the difference between the highest and the lowest Value added (in %) in Textiles and clothing?
Offer a very short reply. 1.77. 